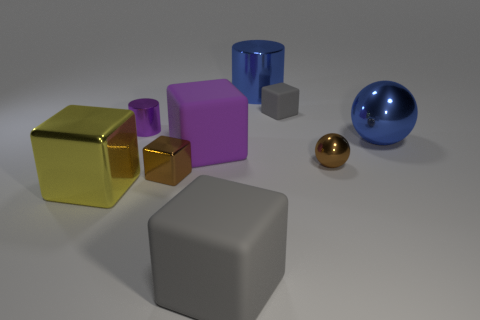Are there any small things made of the same material as the tiny gray block?
Make the answer very short. No. How many things are either blocks that are behind the large purple block or big blocks behind the yellow object?
Your response must be concise. 2. There is a shiny cube to the left of the purple shiny object; does it have the same color as the tiny shiny block?
Give a very brief answer. No. What number of other things are the same color as the big shiny cylinder?
Give a very brief answer. 1. What material is the brown cube?
Your answer should be very brief. Metal. There is a rubber cube that is behind the blue shiny sphere; does it have the same size as the large purple thing?
Your answer should be very brief. No. Is there any other thing that has the same size as the blue metal ball?
Your answer should be very brief. Yes. What is the size of the yellow metal object that is the same shape as the big purple rubber object?
Keep it short and to the point. Large. Are there an equal number of yellow blocks that are behind the purple cube and brown objects that are behind the tiny gray matte object?
Give a very brief answer. Yes. There is a blue object in front of the blue metallic cylinder; what is its size?
Make the answer very short. Large. 